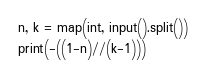Convert code to text. <code><loc_0><loc_0><loc_500><loc_500><_Python_>n, k = map(int, input().split())
print(-((1-n)//(k-1)))</code> 